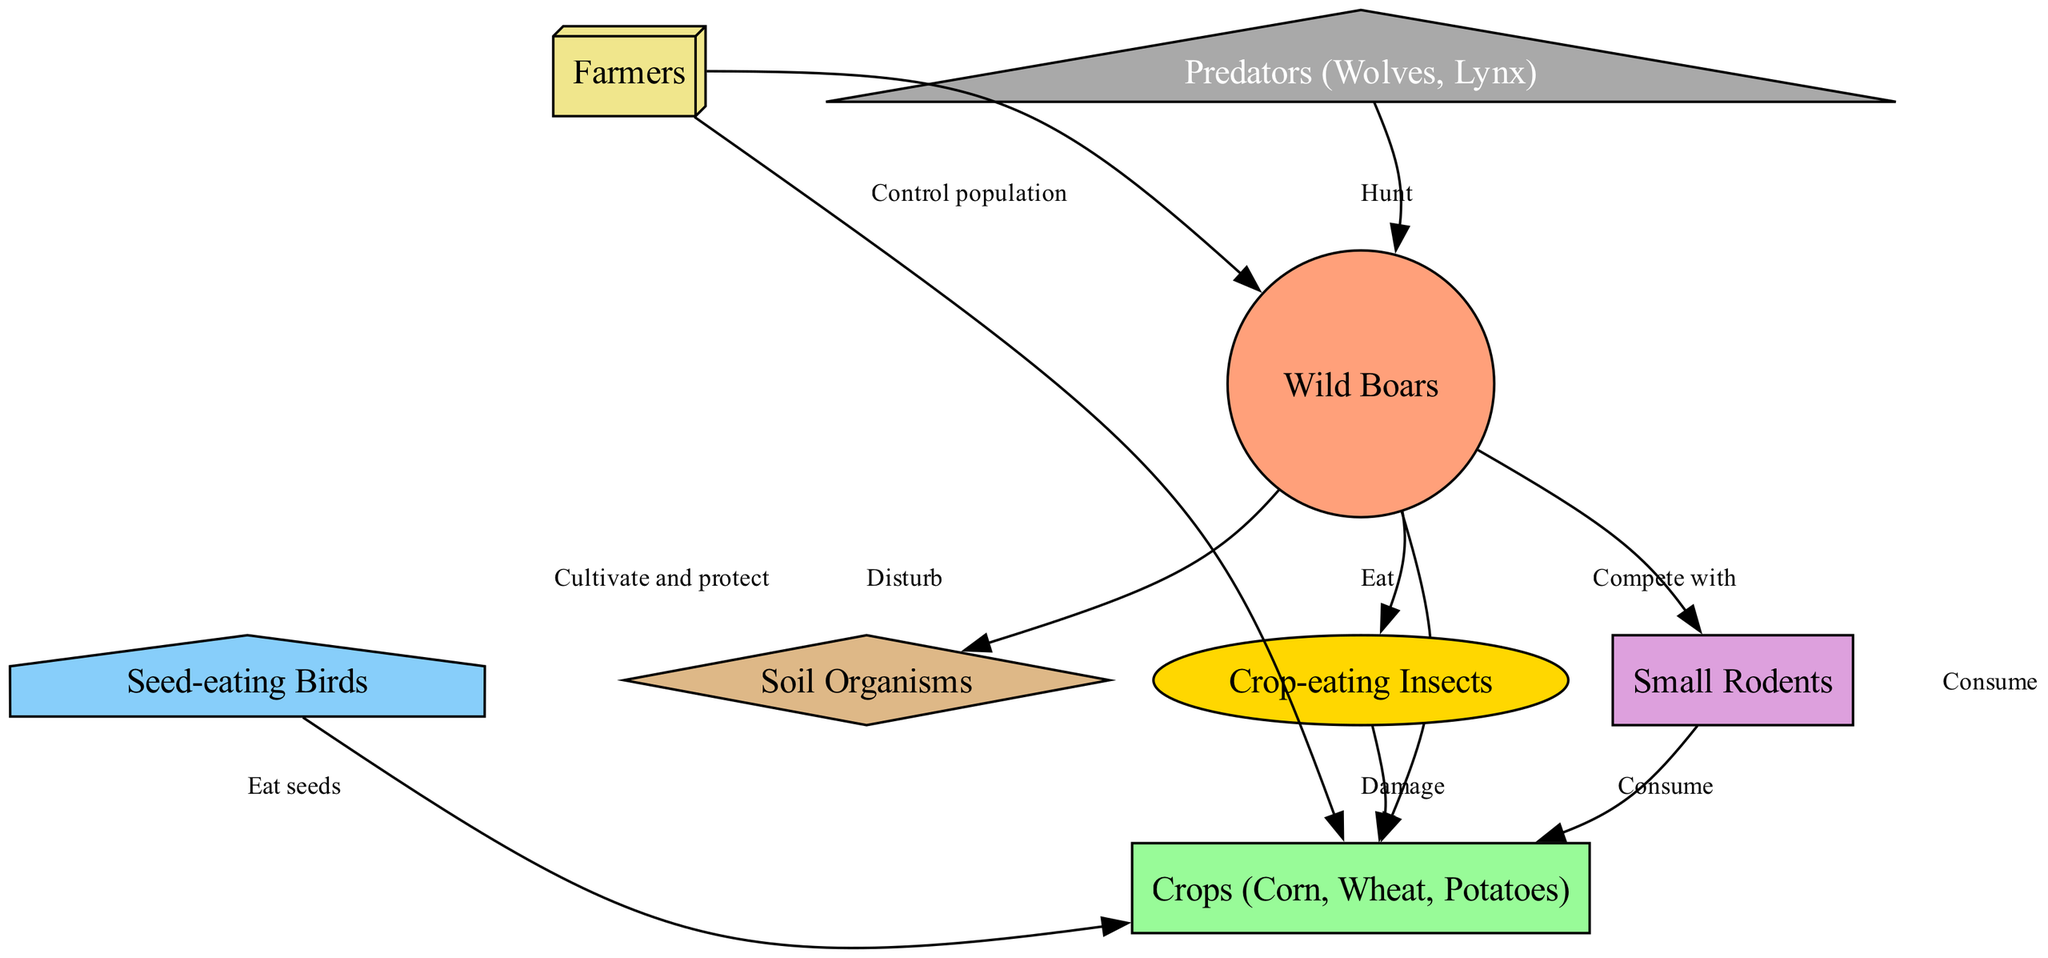What are the nodes present in the diagram? The diagram contains nodes for Wild Boars, Crops, Soil Organisms, Predators, Insects, Birds, Rodents, and Farmers.
Answer: Wild Boars, Crops, Soil Organisms, Predators, Insects, Birds, Rodents, Farmers How many edges are there in total? By counting the connections (edges) between the nodes as listed, there are 10 edges.
Answer: 10 What do wild boars consume? The diagram indicates that wild boars consume crops and insects.
Answer: Crops, Insects Which species competes with wild boars? The diagram shows that small rodents compete with wild boars for resources.
Answer: Small Rodents How do farmers interact with wild boars? Farmers control the population of wild boars as shown in the directed edge connecting the two.
Answer: Control population What effect do insects have on crops? The diagram illustrates that insects cause damage to crops through their consumption.
Answer: Damage Which species are considered predators of wild boars? According to the diagram, wolves and lynx are identified as predators that hunt wild boars.
Answer: Wolves, Lynx What role do farmers have in relation to crops? The diagram indicates that farmers cultivate and protect crops from various threats, including wild boars.
Answer: Cultivate and protect What happens to the crops when wild boars disturb soil organisms? The diagram suggests that disturbances by wild boars may negatively affect crop growth indirectly through soil organisms.
Answer: Negative effect Which type of birds interact with crops? The diagram specifies that seed-eating birds eat seeds from the crops.
Answer: Seed-eating Birds 